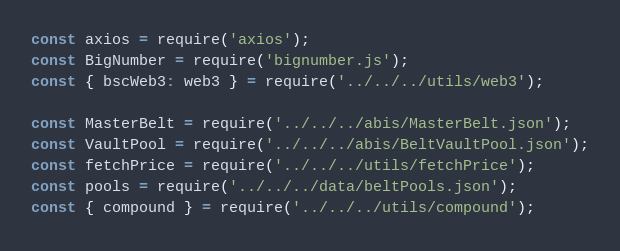Convert code to text. <code><loc_0><loc_0><loc_500><loc_500><_JavaScript_>const axios = require('axios');
const BigNumber = require('bignumber.js');
const { bscWeb3: web3 } = require('../../../utils/web3');

const MasterBelt = require('../../../abis/MasterBelt.json');
const VaultPool = require('../../../abis/BeltVaultPool.json');
const fetchPrice = require('../../../utils/fetchPrice');
const pools = require('../../../data/beltPools.json');
const { compound } = require('../../../utils/compound');</code> 